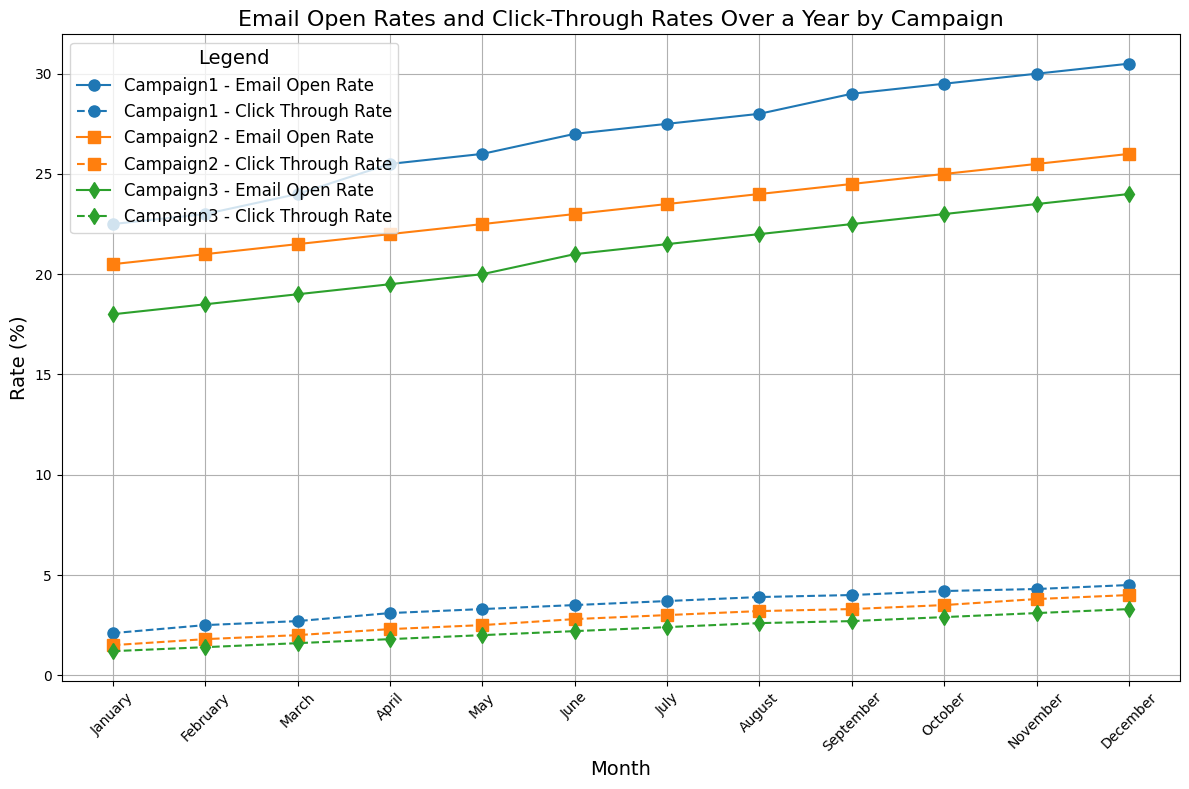What trend can be observed in the Email Open Rates for Campaign1 over the year? The line for Campaign1's Email Open Rates shows a steady upward trend from January to December. This indicates that the open rates are consistently increasing month by month.
Answer: Steady increase Between which two consecutive months did Campaign2 experience the highest increase in Click-Through Rates? By visually examining the Campaign2 Click-Through Rate line (dashed line), the highest increase is observed between January and February. The rate jumps from around 1.5% to 1.8%.
Answer: January and February Which campaign had the highest Email Open Rate in December? Checking the values at the end of the line plot for each campaign in December, Campaign1 has the highest Email Open Rate at 30.5%.
Answer: Campaign1 How much did Campaign3's Click-Through Rate increase from January to December? Subtract the Click-Through Rate in January (1.2%) from that in December (3.3%). 3.3% - 1.2% = 2.1%.
Answer: 2.1% Which campaign had the smallest difference in Email Open Rates from January to December? Calculate differences for each campaign by looking from January to December: Campaign1 (30.5 - 22.5), Campaign2 (26.0 - 20.5), Campaign3 (24.0 - 18.0). Campaign2 has the smallest difference of 5.5%.
Answer: Campaign2 How did the Click-Through Rates compare between Campaign1 and Campaign3 in July? Visually check the dashed lines for both Campaign1 and Campaign3 in July: Campaign1's rate is 3.7%, and Campaign3's rate is 2.4%. Campaign1 is higher.
Answer: Campaign1 is higher Which month shows the highest Click-Through Rate for Campaign2? Follow Campaign2's Click-Through Rate over the months; December shows the highest rate at 4.0%.
Answer: December What is the overall pattern observed in the Click-Through Rates for all campaigns over the year? All campaigns' Click-Through Rates show an upward trend over the year. This indicates increasing engagement over time.
Answer: Upward trend Among the three campaigns, which one has the most consistent growth in Click-Through Rate throughout the year? Examining the trend lines for Click-Through Rates, Campaign2 appears to have the most consistent growth with relatively steady increases each month.
Answer: Campaign2 